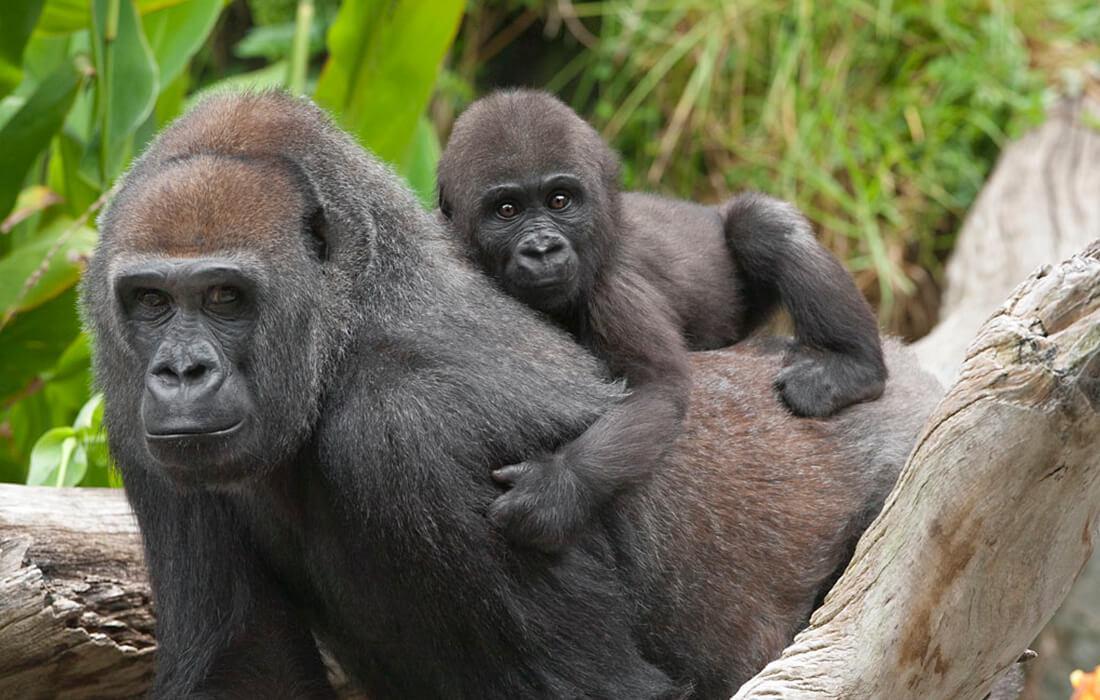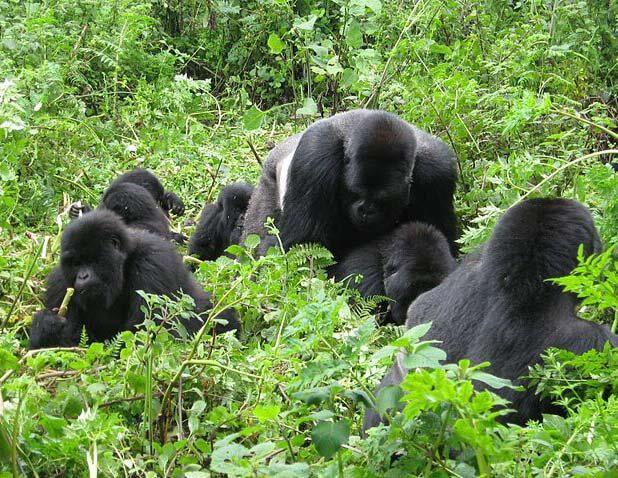The first image is the image on the left, the second image is the image on the right. For the images shown, is this caption "None of the apes are carrying a baby." true? Answer yes or no. No. The first image is the image on the left, the second image is the image on the right. Assess this claim about the two images: "An image contains a single gorilla with brown eyes and soft-looking hair.". Correct or not? Answer yes or no. No. 